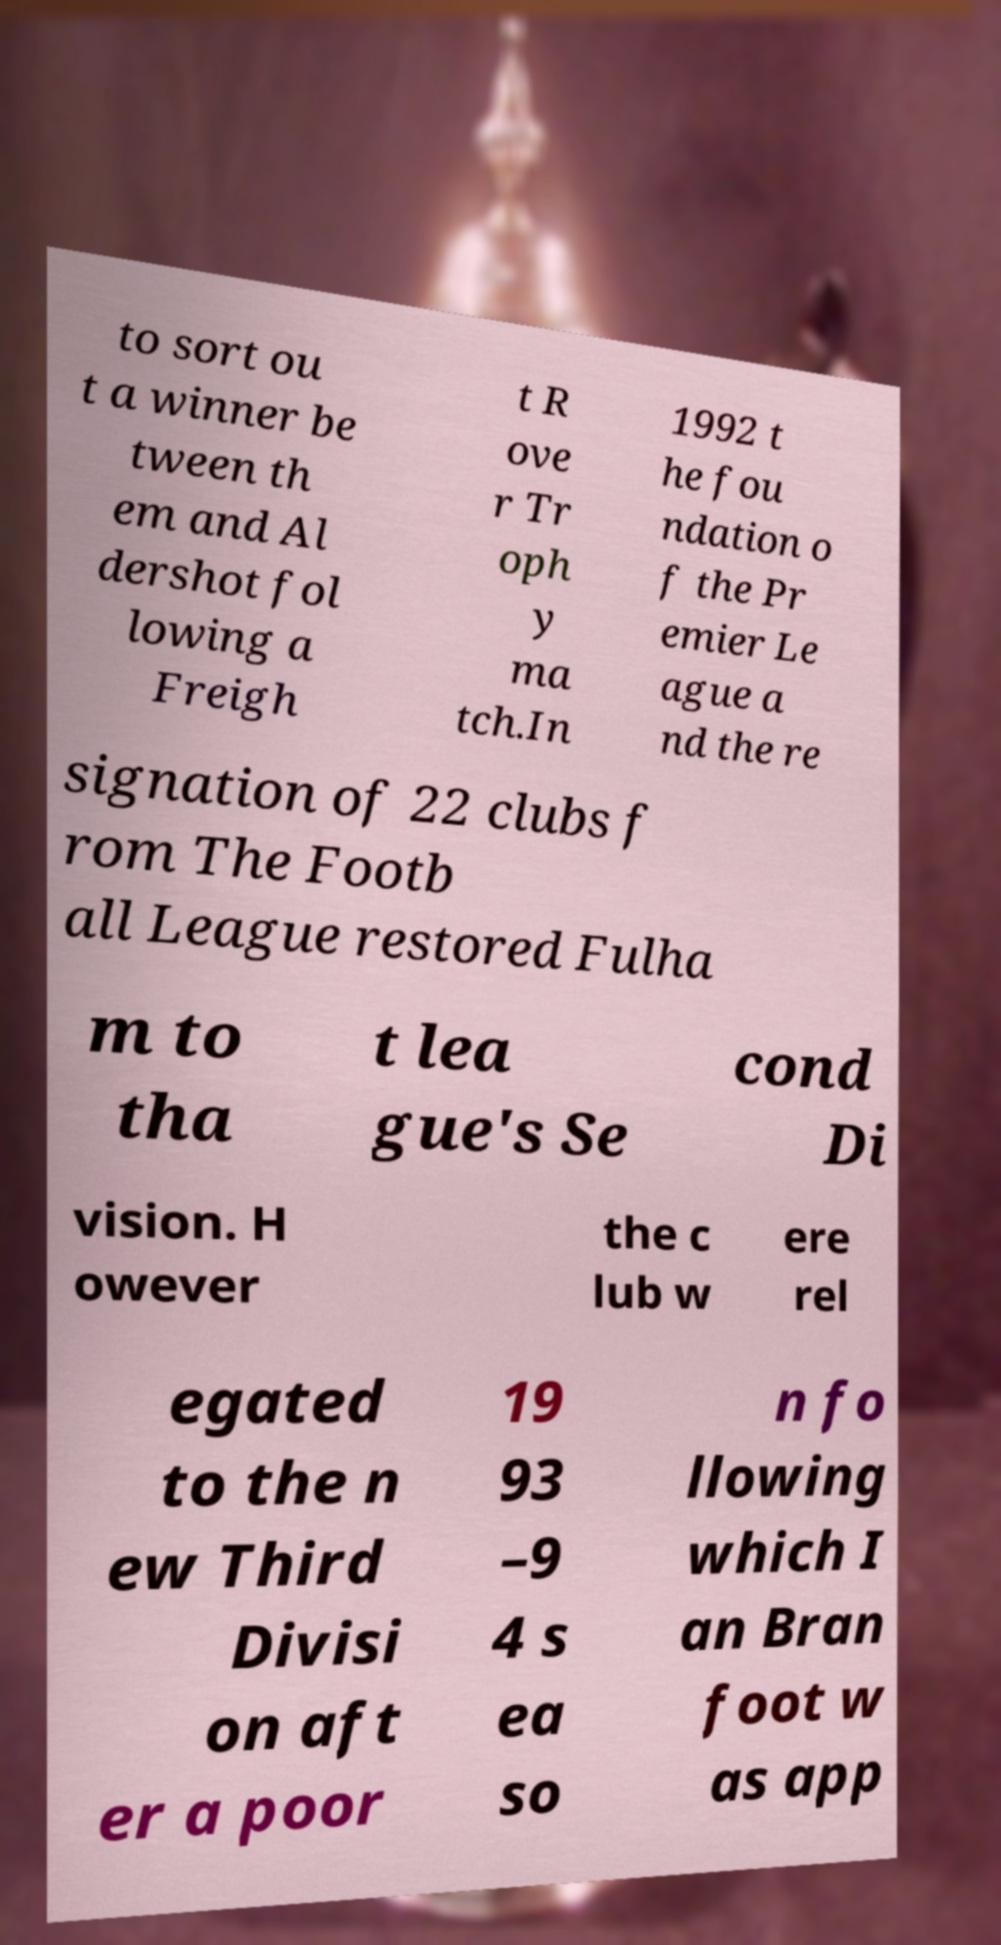Please identify and transcribe the text found in this image. to sort ou t a winner be tween th em and Al dershot fol lowing a Freigh t R ove r Tr oph y ma tch.In 1992 t he fou ndation o f the Pr emier Le ague a nd the re signation of 22 clubs f rom The Footb all League restored Fulha m to tha t lea gue's Se cond Di vision. H owever the c lub w ere rel egated to the n ew Third Divisi on aft er a poor 19 93 –9 4 s ea so n fo llowing which I an Bran foot w as app 